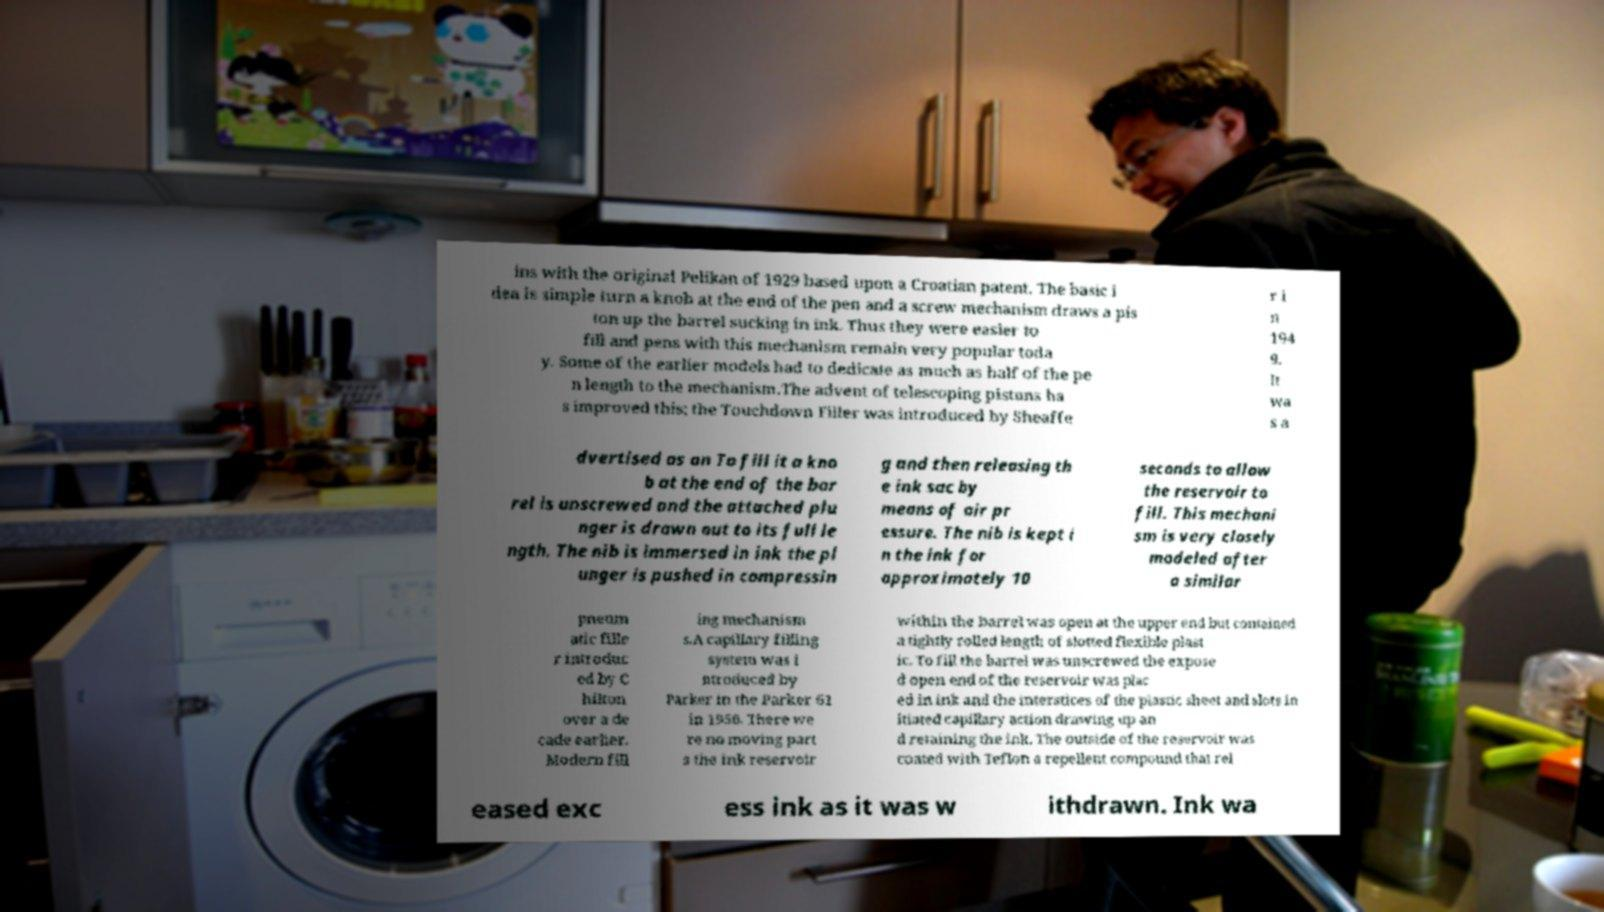There's text embedded in this image that I need extracted. Can you transcribe it verbatim? ins with the original Pelikan of 1929 based upon a Croatian patent. The basic i dea is simple turn a knob at the end of the pen and a screw mechanism draws a pis ton up the barrel sucking in ink. Thus they were easier to fill and pens with this mechanism remain very popular toda y. Some of the earlier models had to dedicate as much as half of the pe n length to the mechanism.The advent of telescoping pistons ha s improved this; the Touchdown Filler was introduced by Sheaffe r i n 194 9. It wa s a dvertised as an To fill it a kno b at the end of the bar rel is unscrewed and the attached plu nger is drawn out to its full le ngth. The nib is immersed in ink the pl unger is pushed in compressin g and then releasing th e ink sac by means of air pr essure. The nib is kept i n the ink for approximately 10 seconds to allow the reservoir to fill. This mechani sm is very closely modeled after a similar pneum atic fille r introduc ed by C hilton over a de cade earlier. Modern fill ing mechanism s.A capillary filling system was i ntroduced by Parker in the Parker 61 in 1956. There we re no moving part s the ink reservoir within the barrel was open at the upper end but contained a tightly rolled length of slotted flexible plast ic. To fill the barrel was unscrewed the expose d open end of the reservoir was plac ed in ink and the interstices of the plastic sheet and slots in itiated capillary action drawing up an d retaining the ink. The outside of the reservoir was coated with Teflon a repellent compound that rel eased exc ess ink as it was w ithdrawn. Ink wa 